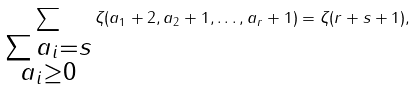<formula> <loc_0><loc_0><loc_500><loc_500>\sum _ { \substack { \sum a _ { i } = s \\ a _ { i } \geq 0 } } \zeta ( a _ { 1 } + 2 , a _ { 2 } + 1 , \dots , a _ { r } + 1 ) = \zeta ( r + s + 1 ) ,</formula> 